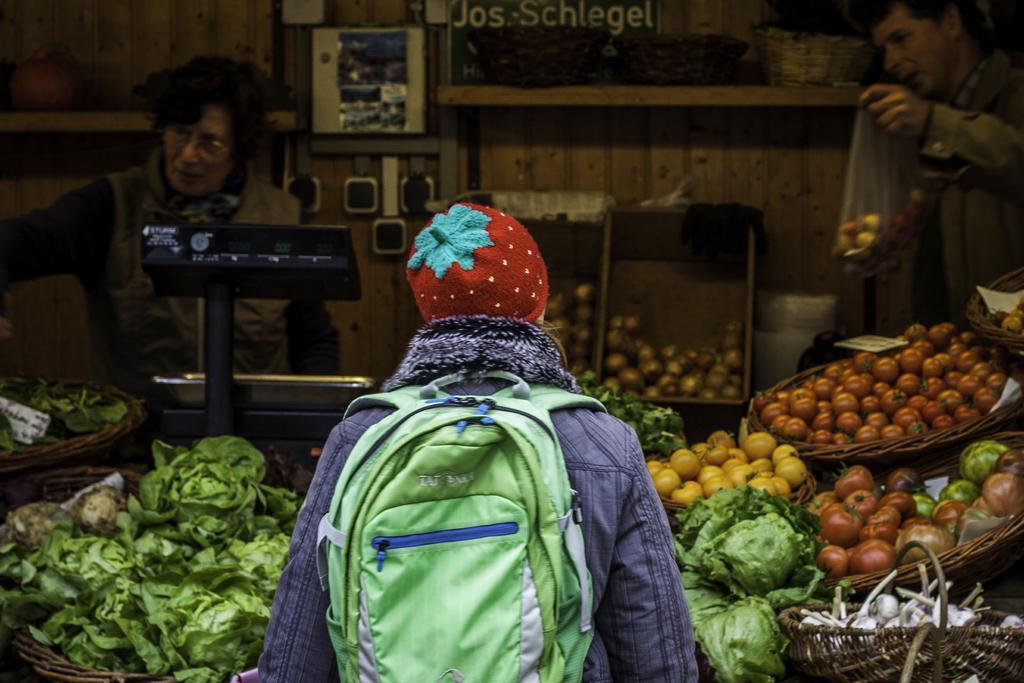Could you give a brief overview of what you see in this image? In this image, in the middle, we can see a person standing and carrying a bag, we can see a vegetable shop, there are two persons standing in the shop, we can see some vegetables. 